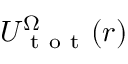Convert formula to latex. <formula><loc_0><loc_0><loc_500><loc_500>U _ { t o t } ^ { \Omega } ( r )</formula> 